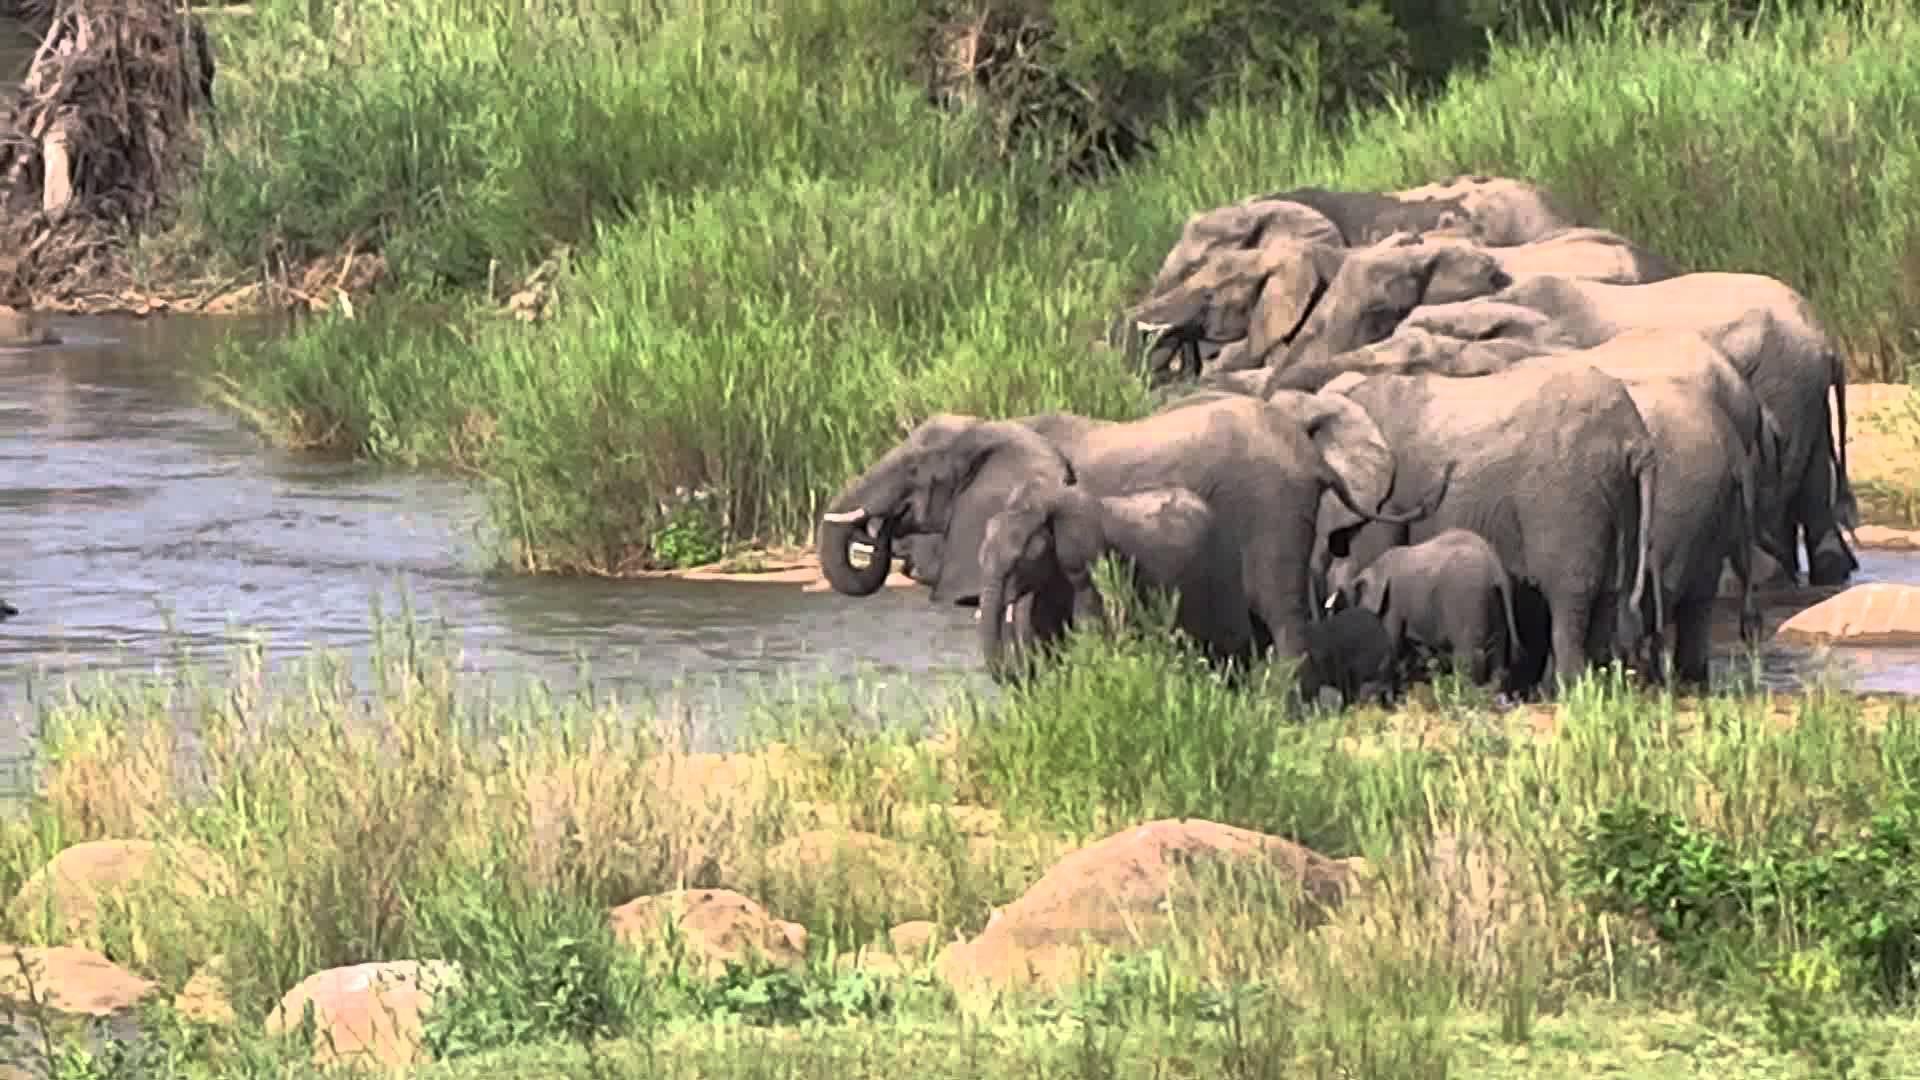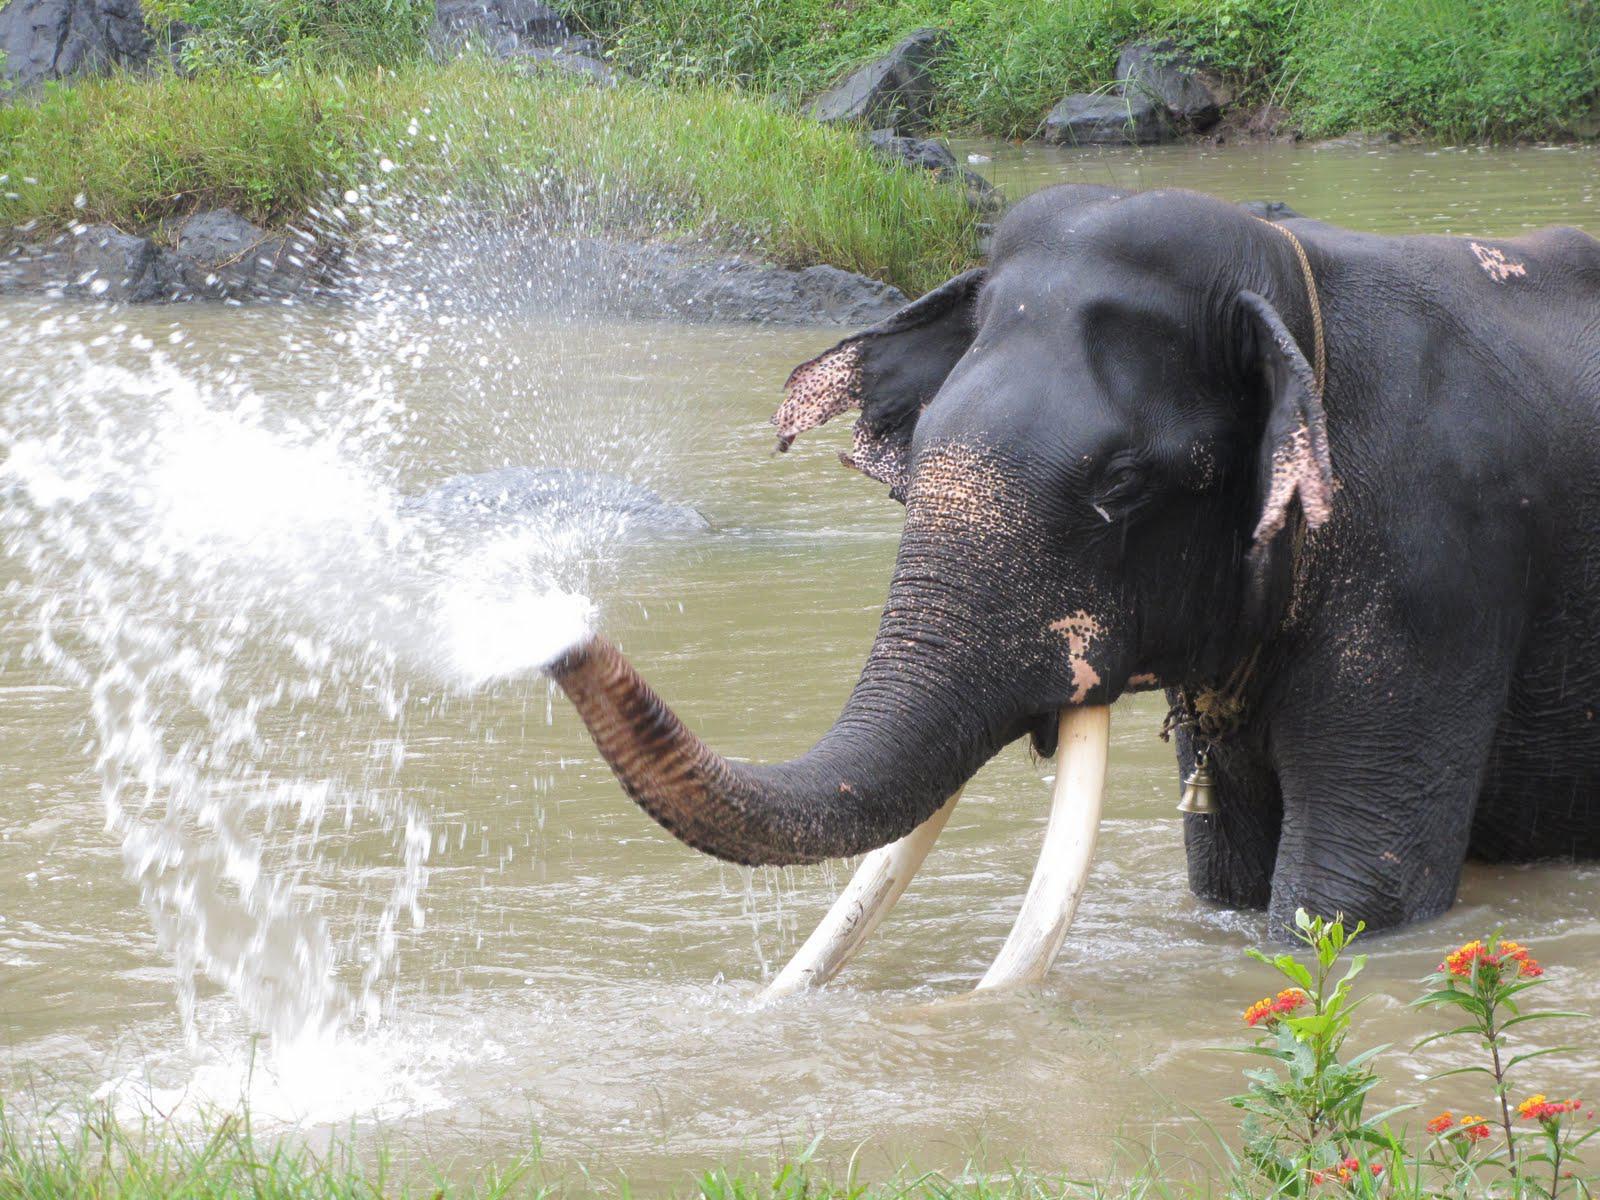The first image is the image on the left, the second image is the image on the right. Evaluate the accuracy of this statement regarding the images: "There are no more than 4 elephants in total.". Is it true? Answer yes or no. No. The first image is the image on the left, the second image is the image on the right. Assess this claim about the two images: "An image shows a person interacting with one elephant.". Correct or not? Answer yes or no. No. 